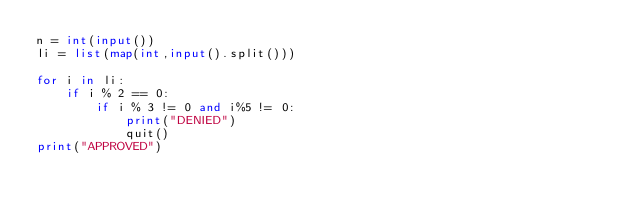<code> <loc_0><loc_0><loc_500><loc_500><_Python_>n = int(input())
li = list(map(int,input().split()))

for i in li:
    if i % 2 == 0:
        if i % 3 != 0 and i%5 != 0:
            print("DENIED")
            quit()
print("APPROVED")
</code> 